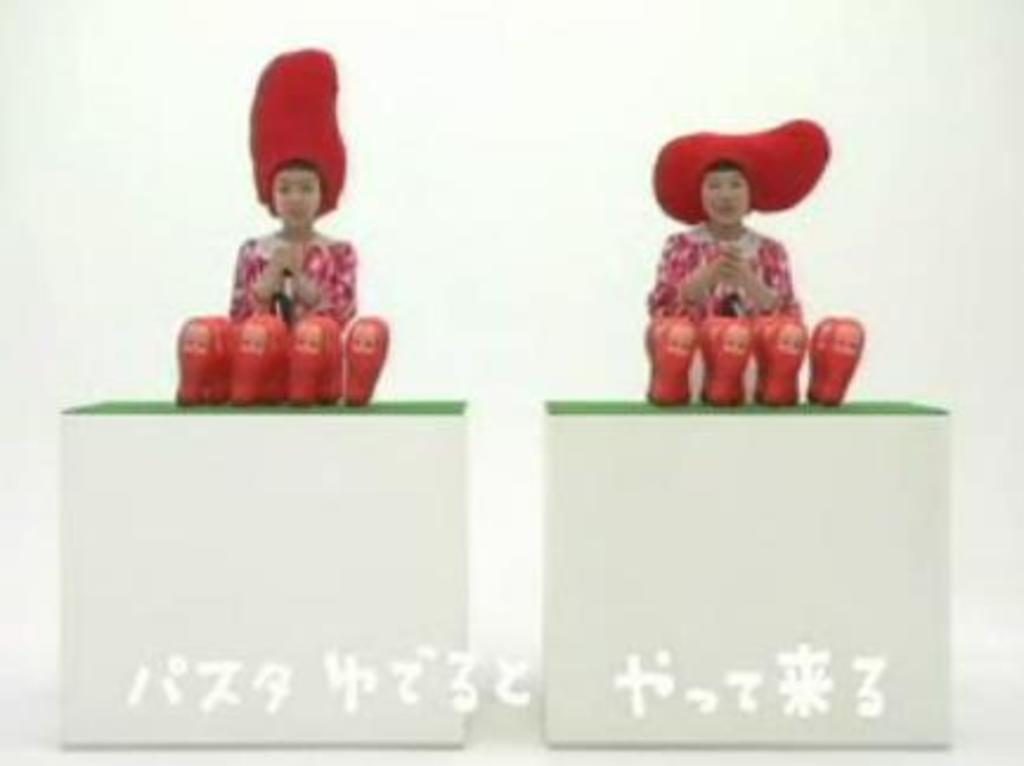What is happening in the image? There are persons standing in the image. What can be seen in front of the persons? There are toys in front of the persons. What is the color of the toys? The toys are red in color. What type of lace is being used to hold the toys together in the image? There is no lace present in the image, nor is there any indication that the toys are being held together. 